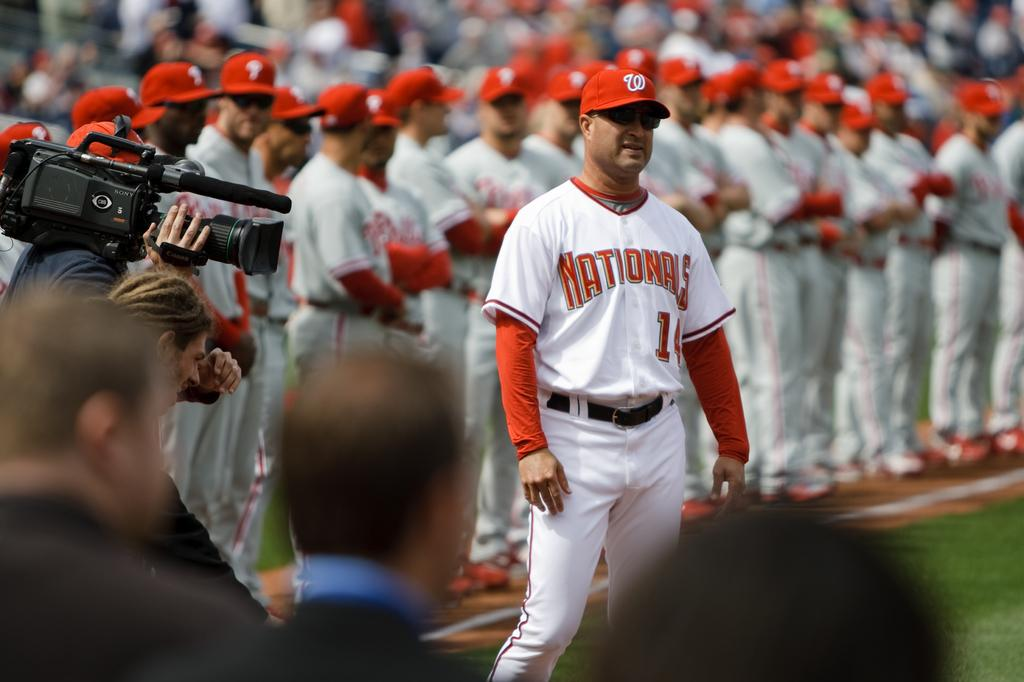<image>
Create a compact narrative representing the image presented. The Nationals baseball team stand up facing forward on the field. 